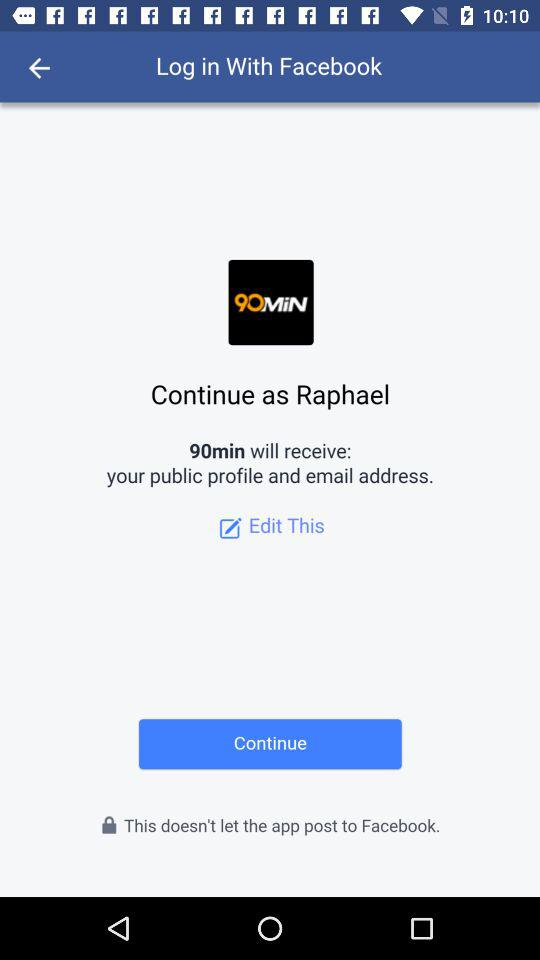What is the user name? The user name is Raphael. 